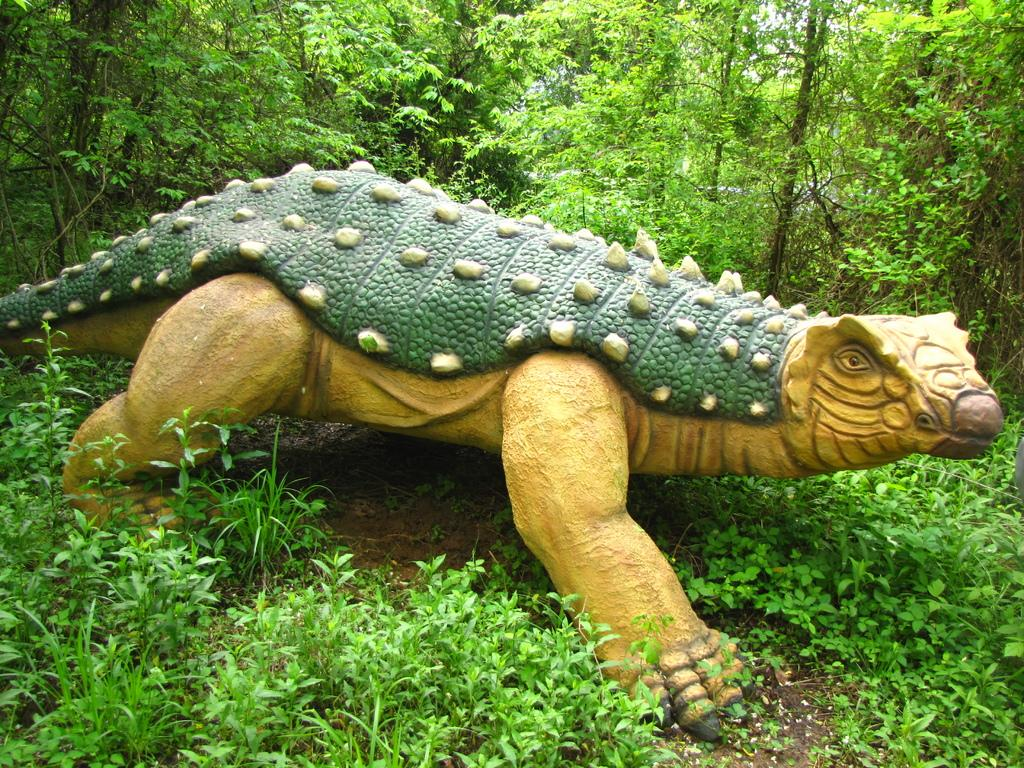What is the main subject of the image? There is a statue of a dinosaur in the image. What other elements can be seen in the image? There are plants and soil on the floor in the image. What can be seen in the background of the image? There are trees in the background of the image. How many ladybugs are crawling on the statue in the image? There are no ladybugs present in the image; the statue is of a dinosaur. What type of fireman is visible in the image? There is no fireman present in the image; it features a statue of a dinosaur and other elements mentioned in the conversation. 